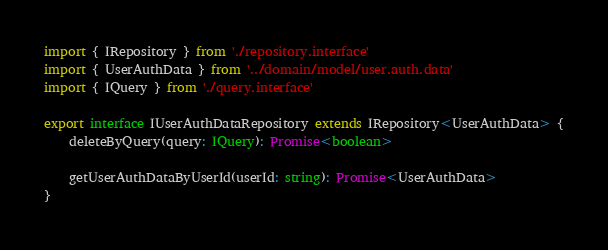<code> <loc_0><loc_0><loc_500><loc_500><_TypeScript_>import { IRepository } from './repository.interface'
import { UserAuthData } from '../domain/model/user.auth.data'
import { IQuery } from './query.interface'

export interface IUserAuthDataRepository extends IRepository<UserAuthData> {
    deleteByQuery(query: IQuery): Promise<boolean>

    getUserAuthDataByUserId(userId: string): Promise<UserAuthData>
}
</code> 